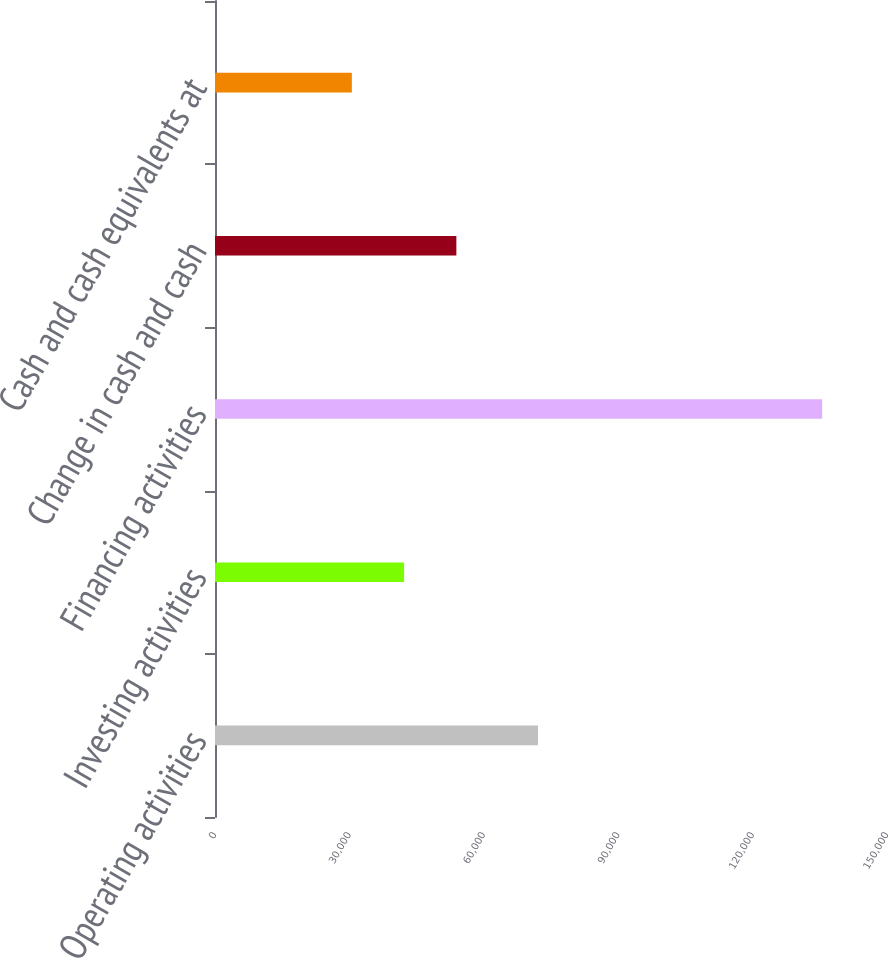<chart> <loc_0><loc_0><loc_500><loc_500><bar_chart><fcel>Operating activities<fcel>Investing activities<fcel>Financing activities<fcel>Change in cash and cash<fcel>Cash and cash equivalents at<nl><fcel>72100<fcel>42211.2<fcel>135532<fcel>53876.3<fcel>30546.1<nl></chart> 